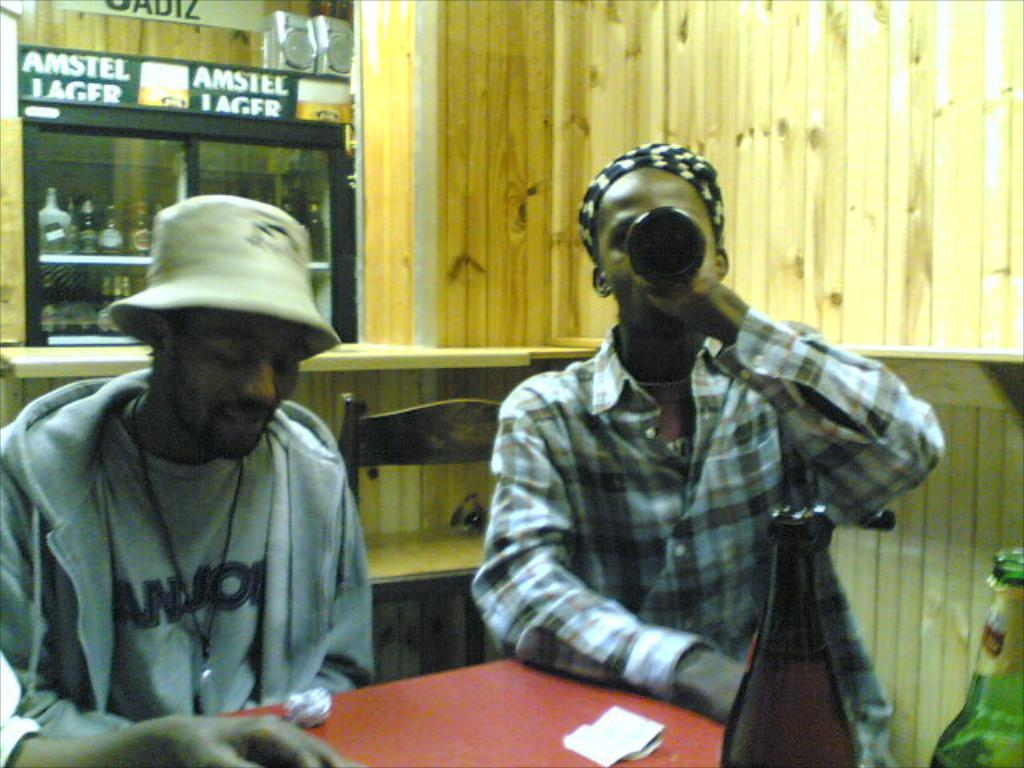What are the people in the image doing? There are persons sitting at a table in the image. What can be seen in the background of the image? There is a refrigerator, beverage bottles, and a wooden wall in the background. What type of road can be seen in the image? There is no road present in the image. What meal are the persons eating in the image? The image does not specify what meal the persons are eating, as it only shows them sitting at a table. 